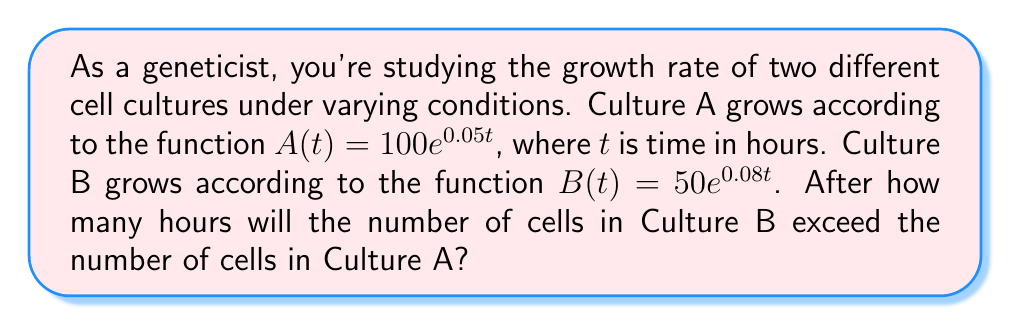Help me with this question. To solve this problem, we need to find the time $t$ when $B(t) > A(t)$. Let's approach this step-by-step:

1) We start with the inequality:
   $B(t) > A(t)$

2) Substitute the given functions:
   $50e^{0.08t} > 100e^{0.05t}$

3) Divide both sides by 50:
   $e^{0.08t} > 2e^{0.05t}$

4) Take the natural logarithm of both sides:
   $\ln(e^{0.08t}) > \ln(2e^{0.05t})$

5) Simplify using the properties of logarithms:
   $0.08t > \ln(2) + 0.05t$

6) Subtract 0.05t from both sides:
   $0.03t > \ln(2)$

7) Divide both sides by 0.03:
   $t > \frac{\ln(2)}{0.03}$

8) Calculate the value:
   $t > \frac{0.693147...}{0.03} \approx 23.105$

Since time must be a whole number of hours in this context, we round up to the next integer.
Answer: Culture B will exceed Culture A after 24 hours. 